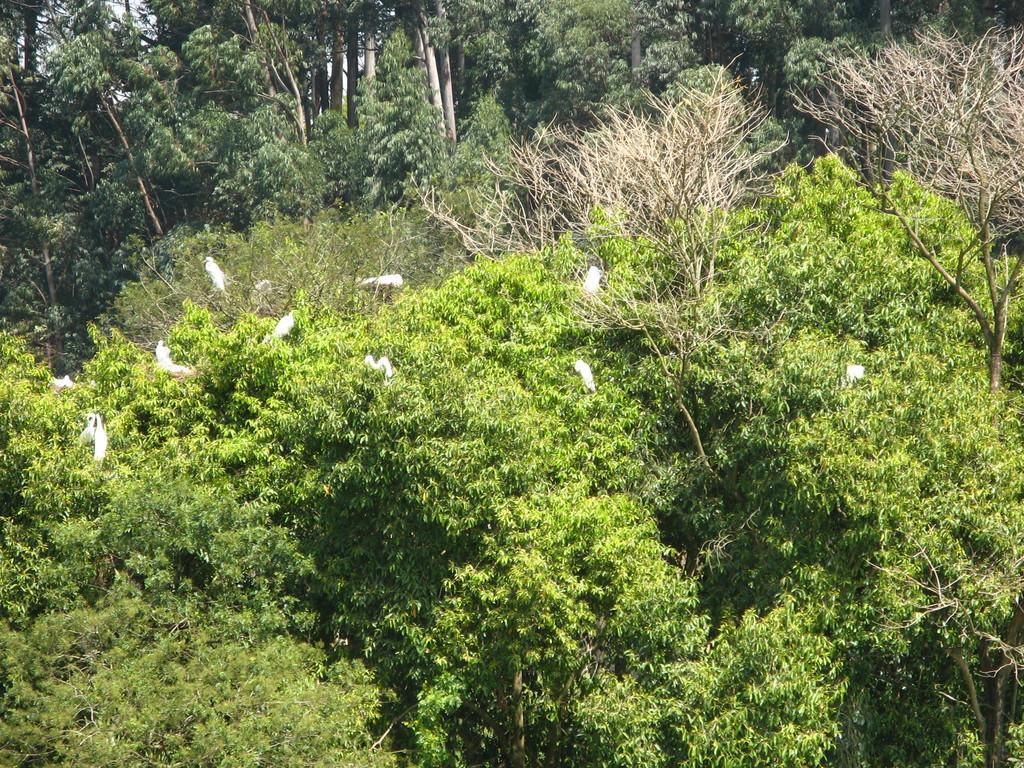Could you give a brief overview of what you see in this image? This picture shows bunch of trees and we see few birds on the trees and birds are white in color. 